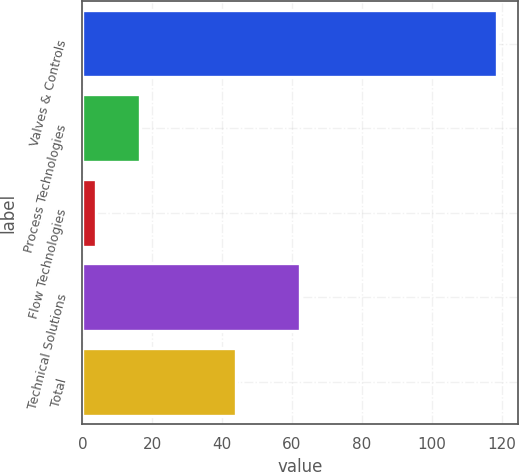Convert chart to OTSL. <chart><loc_0><loc_0><loc_500><loc_500><bar_chart><fcel>Valves & Controls<fcel>Process Technologies<fcel>Flow Technologies<fcel>Technical Solutions<fcel>Total<nl><fcel>118.8<fcel>16.5<fcel>3.9<fcel>62.3<fcel>43.9<nl></chart> 